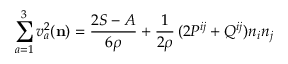Convert formula to latex. <formula><loc_0><loc_0><loc_500><loc_500>\sum _ { a = 1 } ^ { 3 } v _ { a } ^ { 2 } ( { n } ) = \frac { 2 S - A } { 6 \rho } + \frac { 1 } 2 \rho } \, ( 2 P ^ { i j } + Q ^ { i j } ) n _ { i } n _ { j }</formula> 